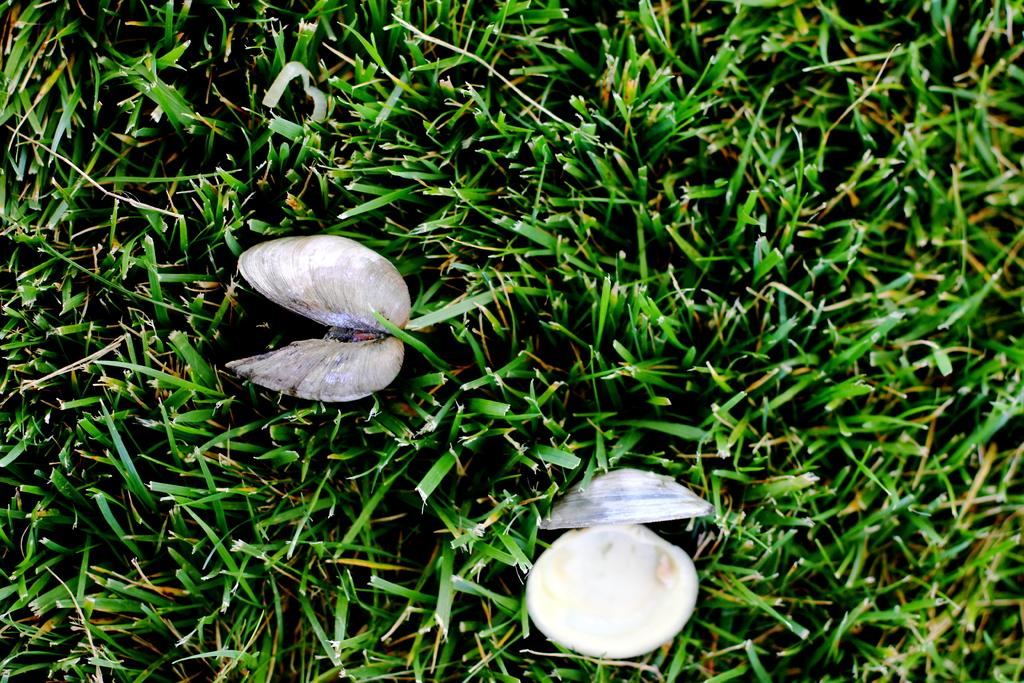What objects can be seen in the image? There are two shells in the image. Where are the shells located? The shells are on the grass. What type of noise can be heard coming from the shells in the image? There is no indication of any noise coming from the shells in the image. 